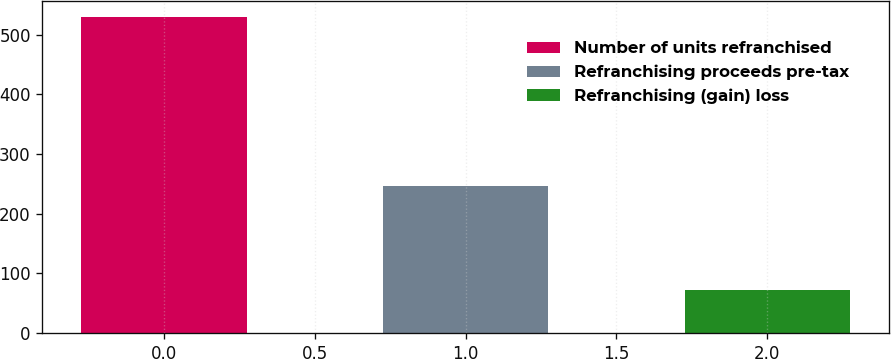Convert chart to OTSL. <chart><loc_0><loc_0><loc_500><loc_500><bar_chart><fcel>Number of units refranchised<fcel>Refranchising proceeds pre-tax<fcel>Refranchising (gain) loss<nl><fcel>529<fcel>246<fcel>72<nl></chart> 